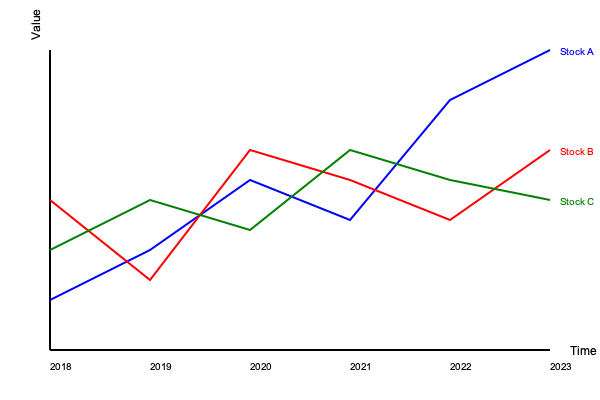Analyze the financial trends depicted in the line graph. Which stock exhibited the highest volatility over the 6-year period, and in which year did all three stocks show a convergence in their values? To answer this question, we need to analyze the graph step-by-step:

1. Volatility:
   - Stock A (blue): Shows significant fluctuations, starting low, peaking in 2022, and ending high in 2023.
   - Stock B (red): Demonstrates moderate fluctuations, with ups and downs throughout the period.
   - Stock C (green): Exhibits the least dramatic changes, maintaining a relatively stable trajectory.

   Stock A shows the highest volatility due to its large price swings.

2. Convergence:
   - We need to identify a year where all three lines are closest to each other.
   - Visually inspecting the graph, we can see that in 2021, all three lines intersect or come very close to each other.

3. Verification:
   - 2018: Lines are spread apart
   - 2019: Lines are spread apart
   - 2020: Lines are closer but not converging
   - 2021: All three lines intersect or come very close to each other
   - 2022: Lines diverge again
   - 2023: Lines are spread apart

Therefore, Stock A exhibited the highest volatility, and all three stocks showed a convergence in their values in 2021.
Answer: Stock A; 2021 